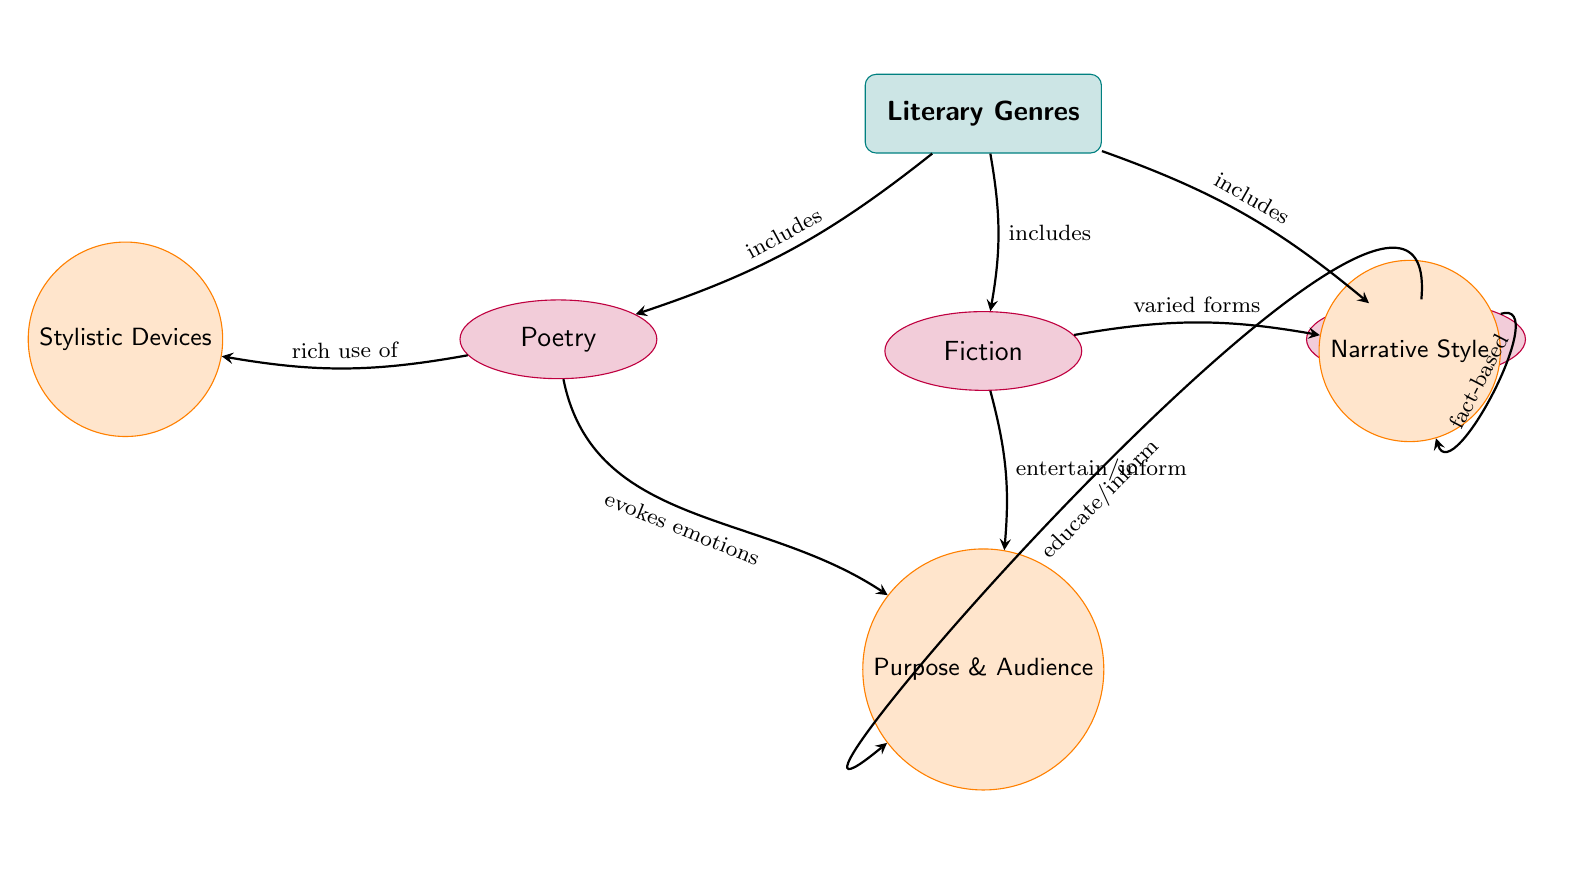What are the three main literary genres included in the diagram? The diagram explicitly lists three genres: Poetry, Fiction, and Non-Fiction as part of the category 'Literary Genres'.
Answer: Poetry, Fiction, Non-Fiction Which genre has a rich use of stylistic devices? In the diagram, an arrow is directed from Poetry to Stylistic Devices, indicating that Poetry is characterized by a rich use of these devices.
Answer: Poetry What is the purpose and audience of Non-Fiction? The arrow from Non-Fiction leads to the phrase 'educate/inform', indicating that Non-Fiction aims to educate or inform its audience.
Answer: educate/inform What type of narrative style is associated with Non-Fiction? The diagram connects Non-Fiction to the phrase 'fact-based' through an arrow, which describes the narrative style typical of Non-Fiction.
Answer: fact-based Which literary genre is noted for evoking emotions? From the diagram, there is an arrow from Poetry that points to 'Purpose & Audience' with the label 'evokes emotions', showing that evoking emotions is a characteristic of Poetry.
Answer: Poetry How many edges are drawn from the genre node to the different literary genres? The diagram shows three arrows emanating from the genre node to Poetry, Fiction, and Non-Fiction, indicating three edges in total.
Answer: 3 Which literary genre includes varied forms in its narrative style? The arrow from Fiction to 'Narrative Style' is labeled 'varied forms', indicating that Fiction includes various forms within its narrative style.
Answer: Fiction What is the connection between Fiction and its purpose/audience? The diagram shows an arrow from Fiction to 'Purpose & Audience' with the label 'entertain/inform', indicating that Fiction serves to entertain or inform its audience.
Answer: entertain/inform Which element in the diagram is drawn closest to Poetry? The element 'Stylistic Devices' is positioned to the left of Poetry in the diagram, making it the closest element to Poetry.
Answer: Stylistic Devices 